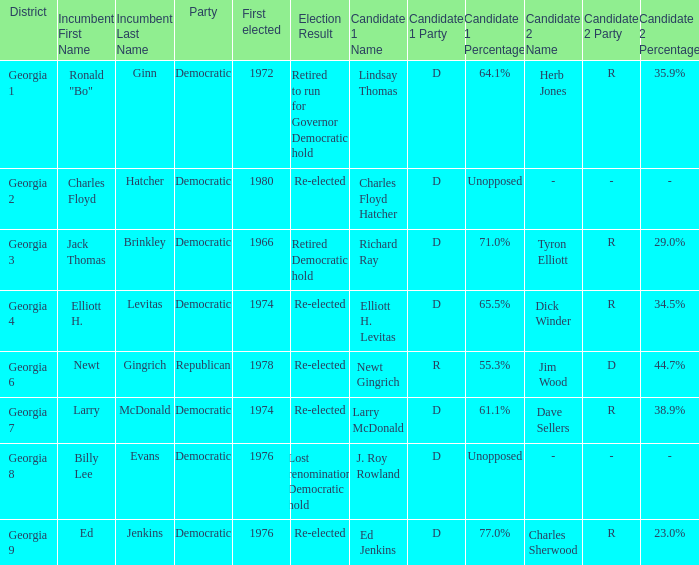Name the districk for larry mcdonald Georgia 7. 